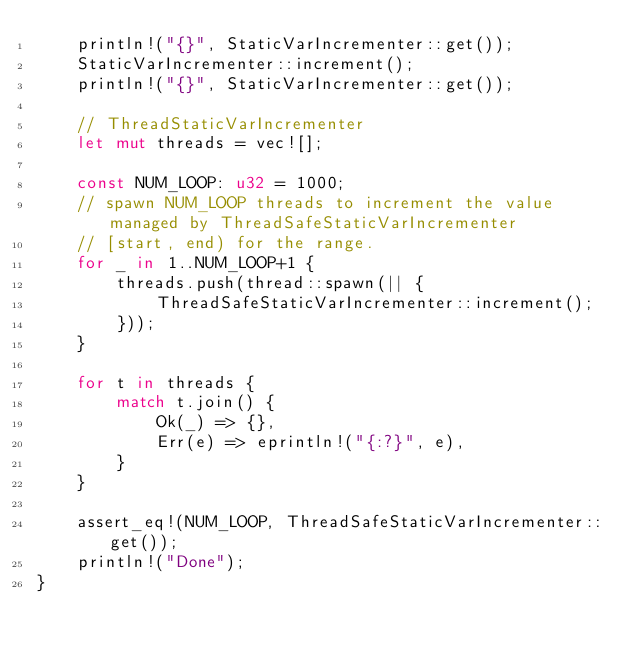<code> <loc_0><loc_0><loc_500><loc_500><_Rust_>    println!("{}", StaticVarIncrementer::get());
    StaticVarIncrementer::increment();
    println!("{}", StaticVarIncrementer::get());

    // ThreadStaticVarIncrementer
    let mut threads = vec![];

    const NUM_LOOP: u32 = 1000;
    // spawn NUM_LOOP threads to increment the value managed by ThreadSafeStaticVarIncrementer
    // [start, end) for the range.
    for _ in 1..NUM_LOOP+1 {
        threads.push(thread::spawn(|| {
            ThreadSafeStaticVarIncrementer::increment();
        }));
    }
    
    for t in threads {
        match t.join() {
            Ok(_) => {},
            Err(e) => eprintln!("{:?}", e),
        }
    }

    assert_eq!(NUM_LOOP, ThreadSafeStaticVarIncrementer::get());
    println!("Done");
}
</code> 